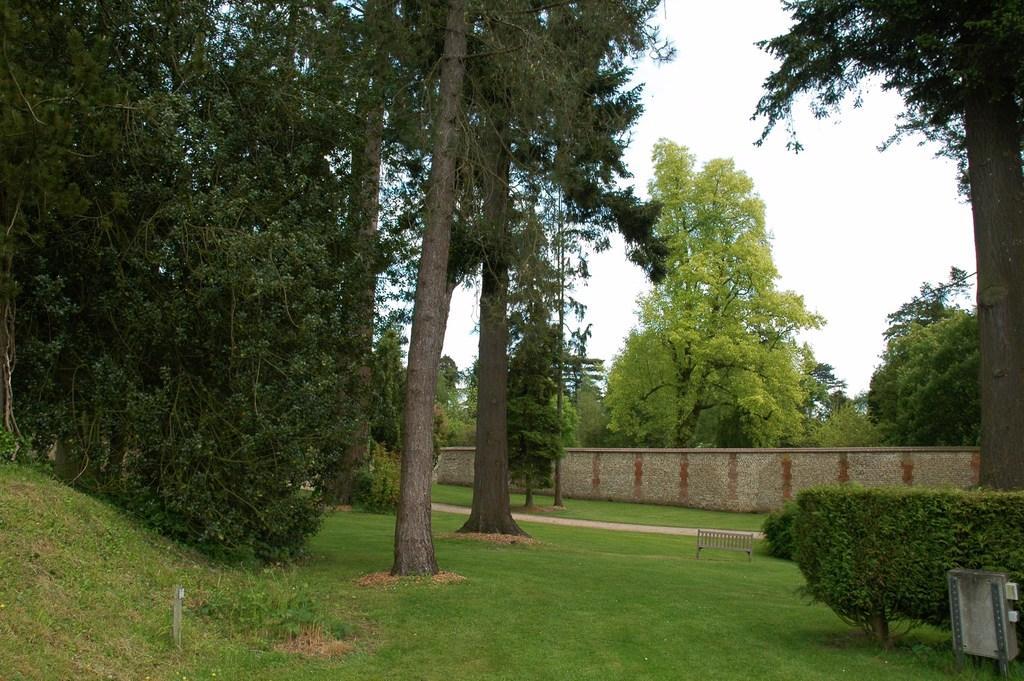Please provide a concise description of this image. In this picture we can see few trees, grass, a bench and a wall, at the right bottom of the image we can see a box. 